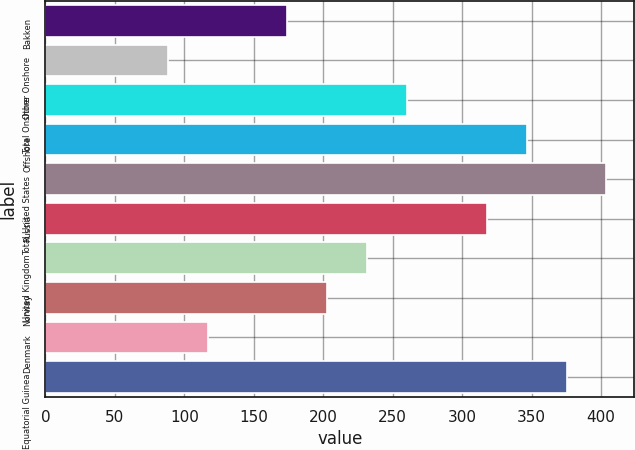<chart> <loc_0><loc_0><loc_500><loc_500><bar_chart><fcel>Bakken<fcel>Other Onshore<fcel>Total Onshore<fcel>Offshore<fcel>Total United States<fcel>Russia<fcel>United Kingdom<fcel>Norway<fcel>Denmark<fcel>Equatorial Guinea<nl><fcel>174.2<fcel>88.1<fcel>260.3<fcel>346.4<fcel>403.8<fcel>317.7<fcel>231.6<fcel>202.9<fcel>116.8<fcel>375.1<nl></chart> 